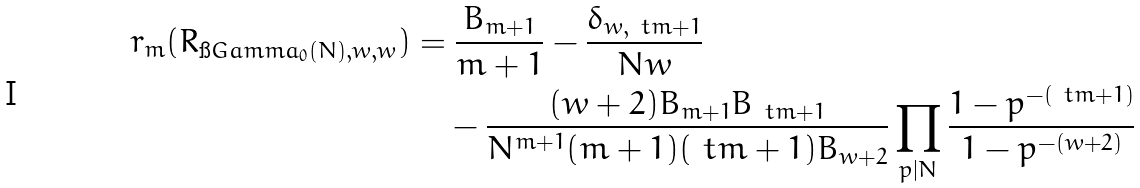<formula> <loc_0><loc_0><loc_500><loc_500>r _ { m } ( R _ { \i G a m m a _ { 0 } ( N ) , w , w } ) & = \frac { B _ { m + 1 } } { m + 1 } - \frac { \delta _ { w , \ t m + 1 } } { N w } \\ & \quad - \frac { ( w + 2 ) B _ { m + 1 } B _ { \ t m + 1 } } { N ^ { m + 1 } ( m + 1 ) ( \ t m + 1 ) B _ { w + 2 } } \prod _ { p | N } \frac { 1 - p ^ { - ( \ t m + 1 ) } } { 1 - p ^ { - ( w + 2 ) } }</formula> 